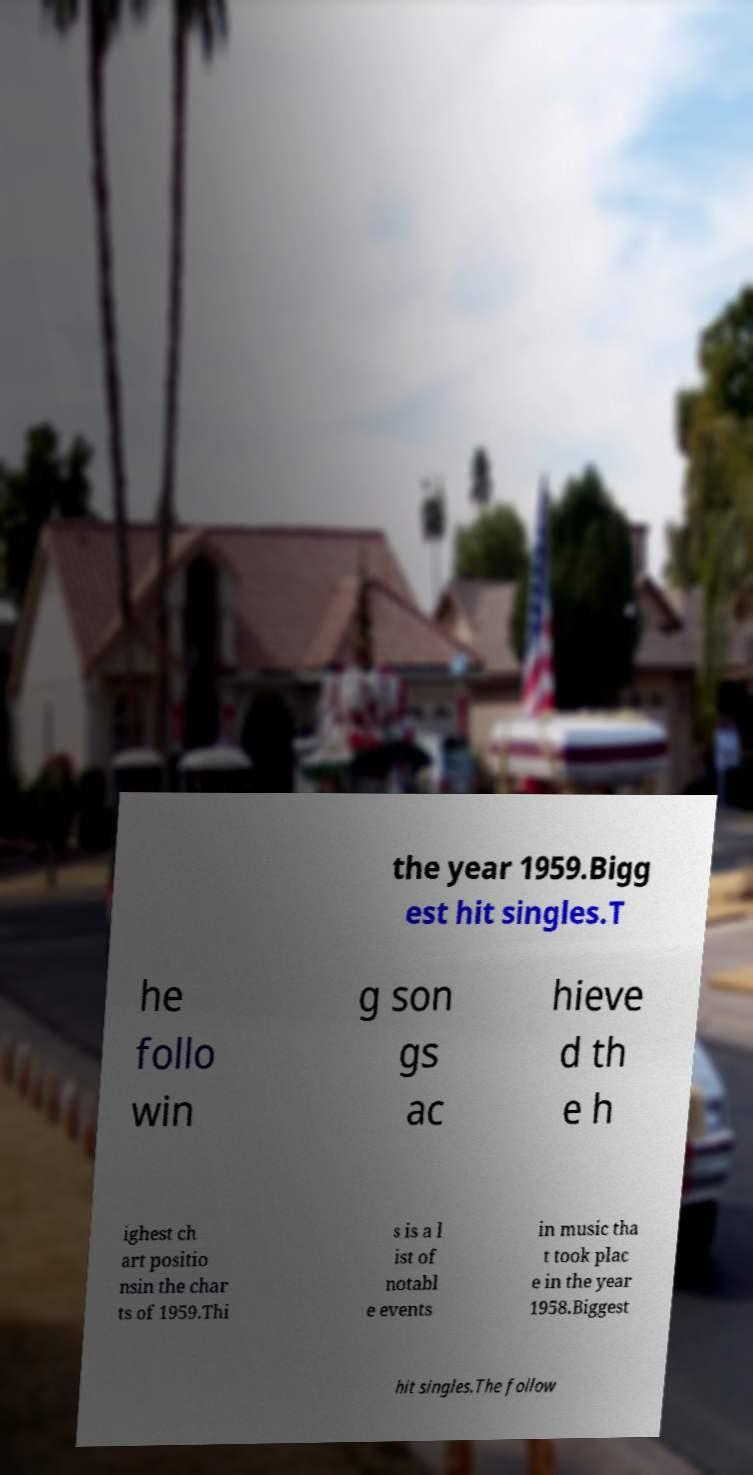What messages or text are displayed in this image? I need them in a readable, typed format. the year 1959.Bigg est hit singles.T he follo win g son gs ac hieve d th e h ighest ch art positio nsin the char ts of 1959.Thi s is a l ist of notabl e events in music tha t took plac e in the year 1958.Biggest hit singles.The follow 